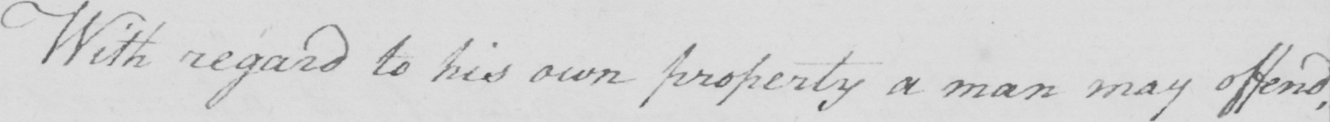Please provide the text content of this handwritten line. With regard to his own property a man may offend , 